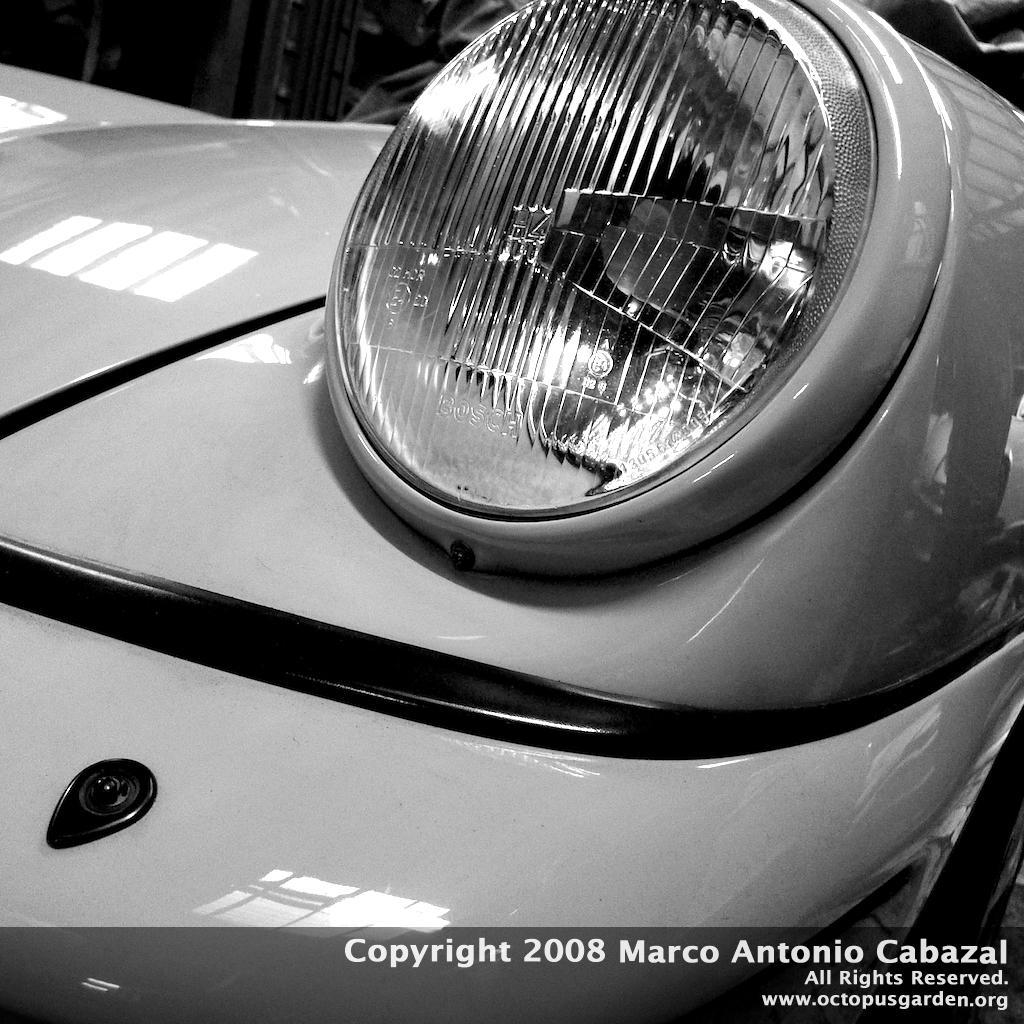Can you describe this image briefly? In this picture there is a vehicle in the foreground. At the back it looks like a person. At the bottom there is text. 